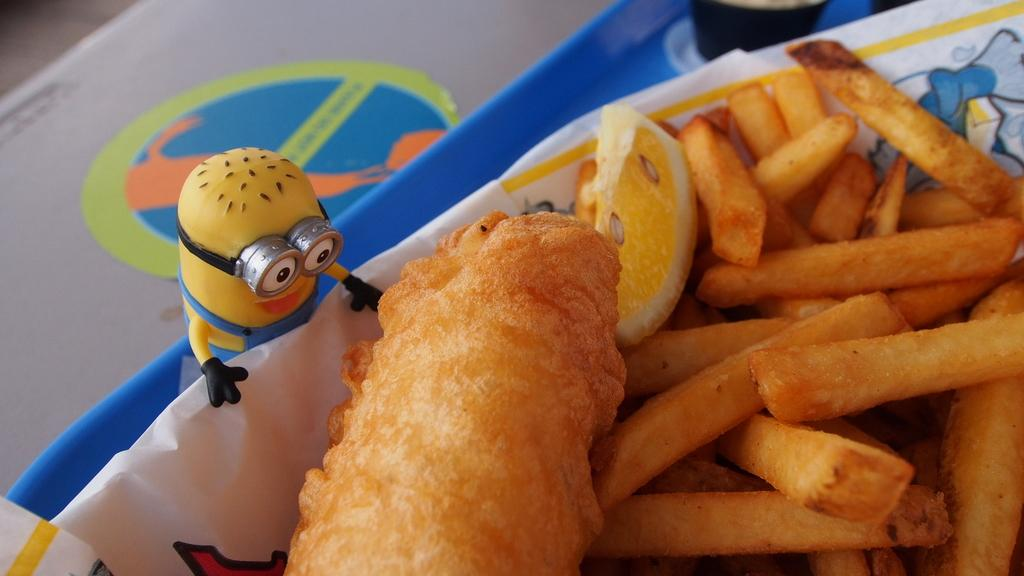What is on the plate in the image? There is food in a plate in the image. What can be seen on the left side of the image? There is a toy on the left side of the image. Can you describe any other objects in the image? There are other objects in the image, but their specific details are not mentioned in the provided facts. What type of lipstick is the sheep wearing in the image? There is no sheep or lipstick present in the image. 